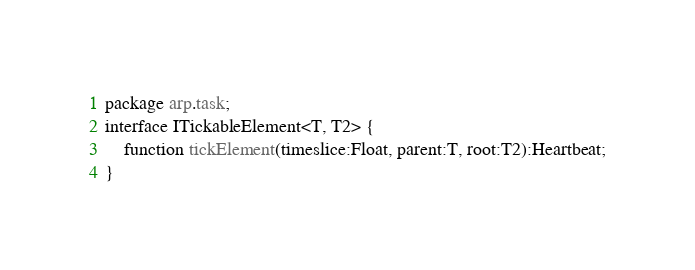Convert code to text. <code><loc_0><loc_0><loc_500><loc_500><_Haxe_>package arp.task;
interface ITickableElement<T, T2> {
	function tickElement(timeslice:Float, parent:T, root:T2):Heartbeat;
}
</code> 